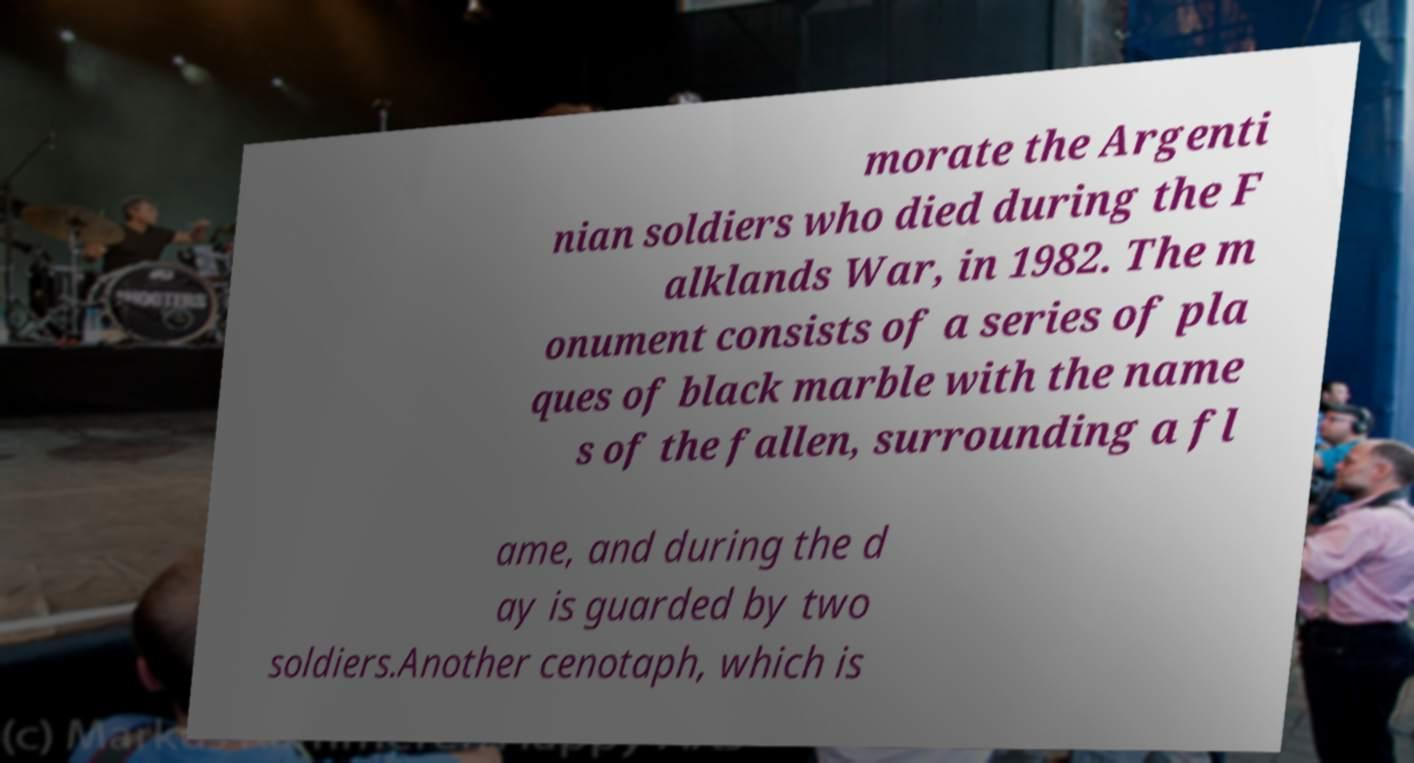Please read and relay the text visible in this image. What does it say? morate the Argenti nian soldiers who died during the F alklands War, in 1982. The m onument consists of a series of pla ques of black marble with the name s of the fallen, surrounding a fl ame, and during the d ay is guarded by two soldiers.Another cenotaph, which is 